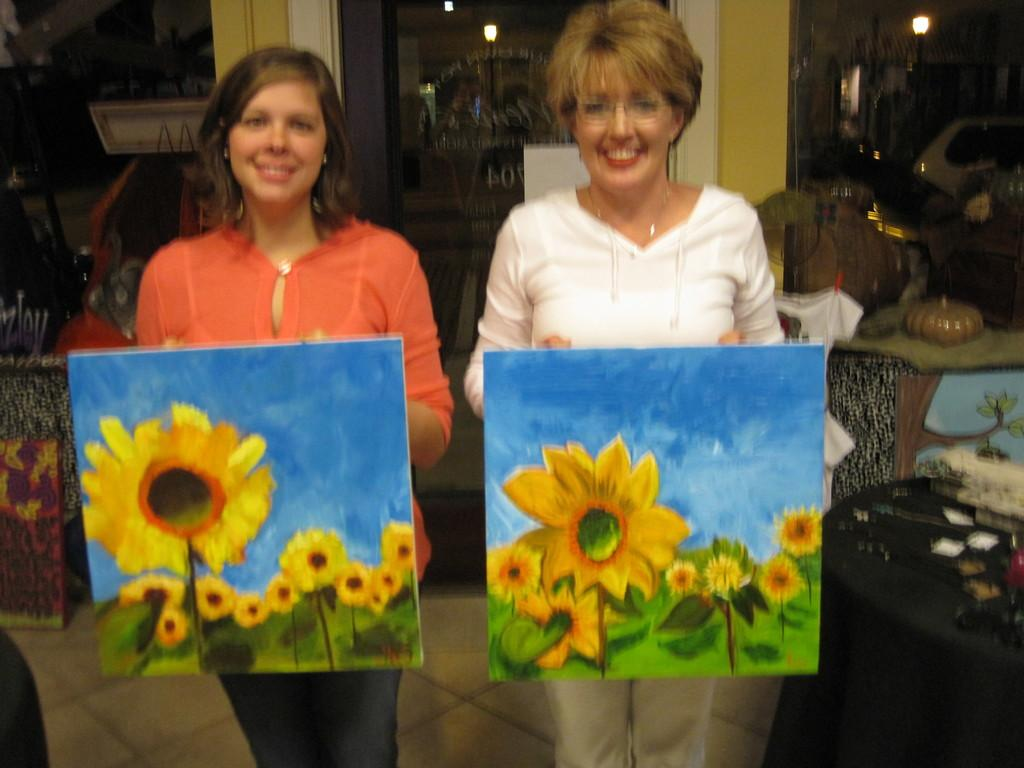How many women are in the image? There are two women in the image. What are the women holding in the image? The women are holding posters in the image. What can be seen in the background of the image? There is a table, lights, the floor, pillars, and some objects visible in the background of the image. What type of van can be seen in the image? There is no van present in the image. Can you describe the coach that the women are sitting on in the image? There is no coach present in the image; the women are holding posters. 